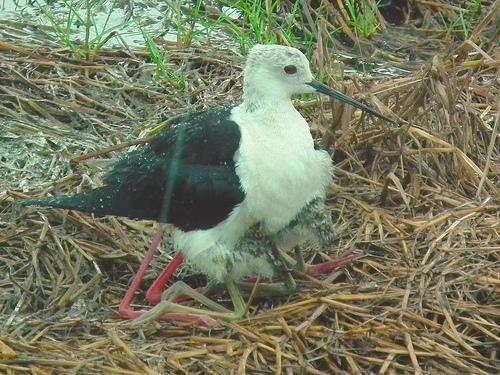How many animals are shown?
Give a very brief answer. 1. 